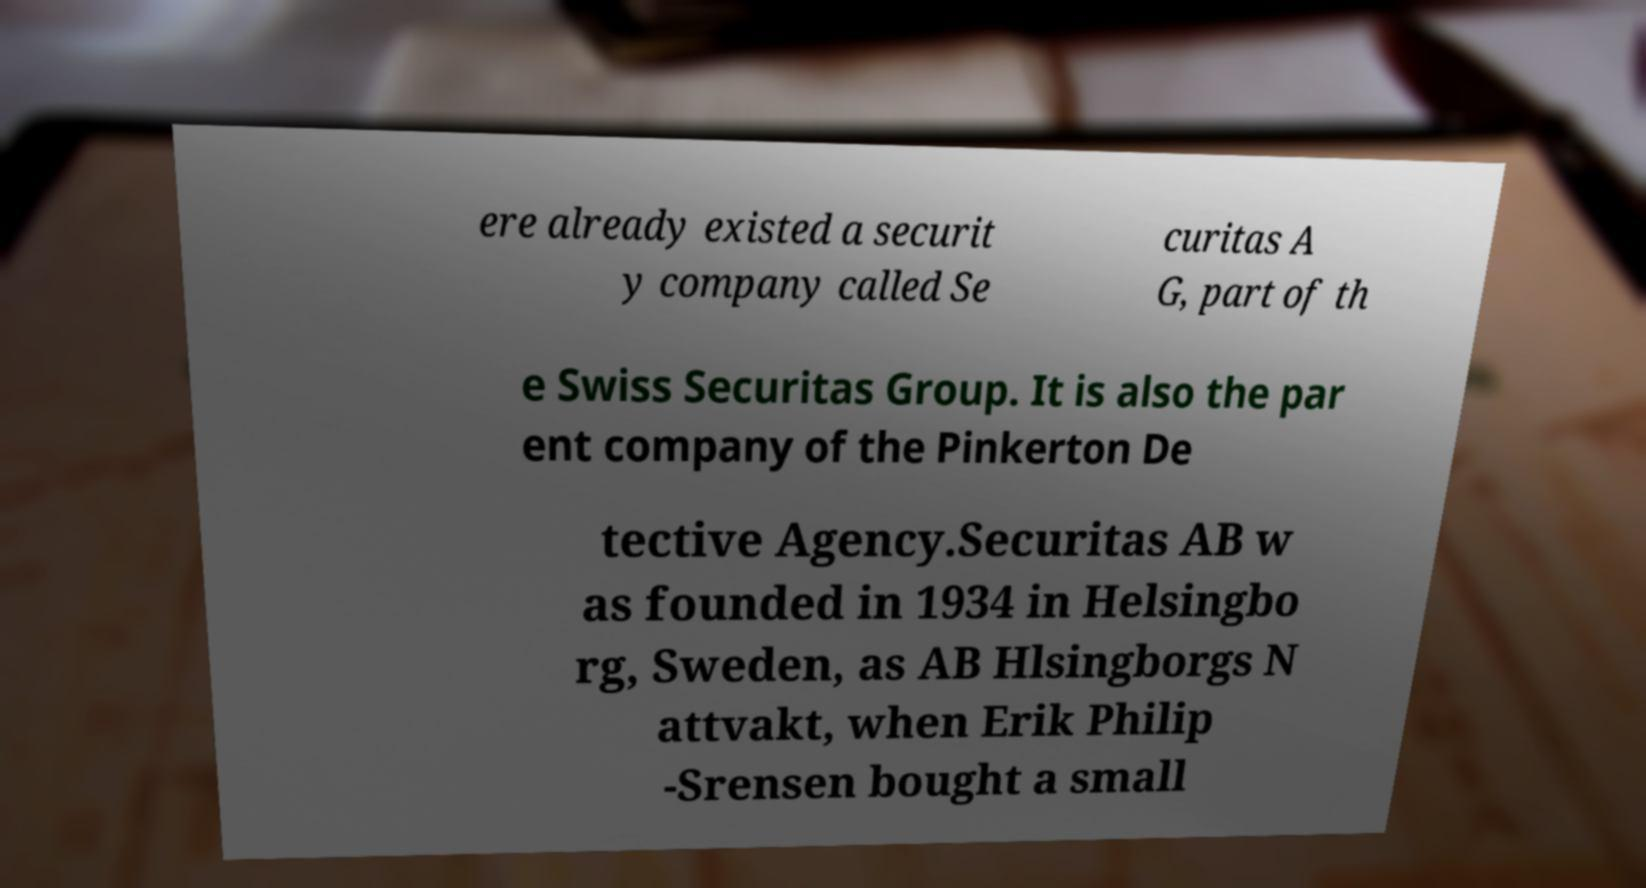Please identify and transcribe the text found in this image. ere already existed a securit y company called Se curitas A G, part of th e Swiss Securitas Group. It is also the par ent company of the Pinkerton De tective Agency.Securitas AB w as founded in 1934 in Helsingbo rg, Sweden, as AB Hlsingborgs N attvakt, when Erik Philip -Srensen bought a small 